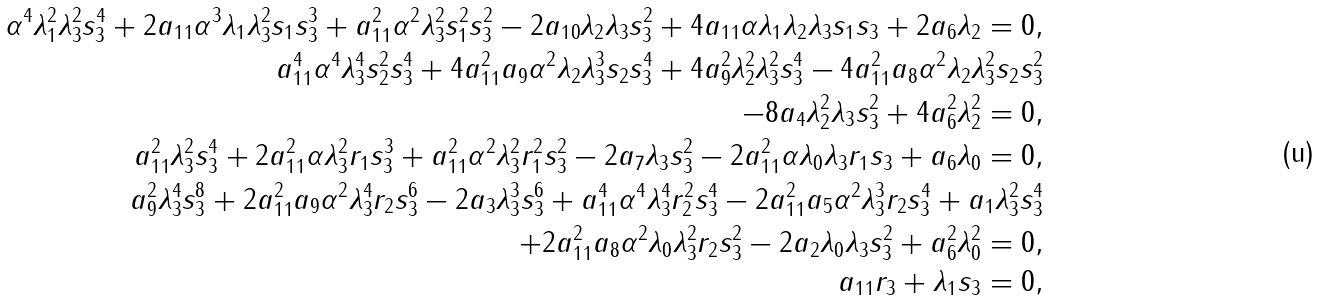<formula> <loc_0><loc_0><loc_500><loc_500>\alpha ^ { 4 } \lambda _ { 1 } ^ { 2 } \lambda _ { 3 } ^ { 2 } s _ { 3 } ^ { 4 } + 2 a _ { 1 1 } \alpha ^ { 3 } \lambda _ { 1 } \lambda _ { 3 } ^ { 2 } s _ { 1 } s _ { 3 } ^ { 3 } + a _ { 1 1 } ^ { 2 } \alpha ^ { 2 } \lambda _ { 3 } ^ { 2 } s _ { 1 } ^ { 2 } s _ { 3 } ^ { 2 } - 2 a _ { 1 0 } \lambda _ { 2 } \lambda _ { 3 } s _ { 3 } ^ { 2 } + 4 a _ { 1 1 } \alpha \lambda _ { 1 } \lambda _ { 2 } \lambda _ { 3 } s _ { 1 } s _ { 3 } + 2 a _ { 6 } \lambda _ { 2 } = 0 , \\ a _ { 1 1 } ^ { 4 } \alpha ^ { 4 } \lambda _ { 3 } ^ { 4 } s _ { 2 } ^ { 2 } s _ { 3 } ^ { 4 } + 4 a _ { 1 1 } ^ { 2 } a _ { 9 } \alpha ^ { 2 } \lambda _ { 2 } \lambda _ { 3 } ^ { 3 } s _ { 2 } s _ { 3 } ^ { 4 } + 4 a _ { 9 } ^ { 2 } \lambda _ { 2 } ^ { 2 } \lambda _ { 3 } ^ { 2 } s _ { 3 } ^ { 4 } - 4 a _ { 1 1 } ^ { 2 } a _ { 8 } \alpha ^ { 2 } \lambda _ { 2 } \lambda _ { 3 } ^ { 2 } s _ { 2 } s _ { 3 } ^ { 2 } \\ - 8 a _ { 4 } \lambda _ { 2 } ^ { 2 } \lambda _ { 3 } s _ { 3 } ^ { 2 } + 4 a _ { 6 } ^ { 2 } \lambda _ { 2 } ^ { 2 } = 0 , \\ a _ { 1 1 } ^ { 2 } \lambda _ { 3 } ^ { 2 } s _ { 3 } ^ { 4 } + 2 a _ { 1 1 } ^ { 2 } \alpha \lambda _ { 3 } ^ { 2 } r _ { 1 } s _ { 3 } ^ { 3 } + a _ { 1 1 } ^ { 2 } \alpha ^ { 2 } \lambda _ { 3 } ^ { 2 } r _ { 1 } ^ { 2 } s _ { 3 } ^ { 2 } - 2 a _ { 7 } \lambda _ { 3 } s _ { 3 } ^ { 2 } - 2 a _ { 1 1 } ^ { 2 } \alpha \lambda _ { 0 } \lambda _ { 3 } r _ { 1 } s _ { 3 } + a _ { 6 } \lambda _ { 0 } = 0 , \\ a _ { 9 } ^ { 2 } \lambda _ { 3 } ^ { 4 } s _ { 3 } ^ { 8 } + 2 a _ { 1 1 } ^ { 2 } a _ { 9 } \alpha ^ { 2 } \lambda _ { 3 } ^ { 4 } r _ { 2 } s _ { 3 } ^ { 6 } - 2 a _ { 3 } \lambda _ { 3 } ^ { 3 } s _ { 3 } ^ { 6 } + a _ { 1 1 } ^ { 4 } \alpha ^ { 4 } \lambda _ { 3 } ^ { 4 } r _ { 2 } ^ { 2 } s _ { 3 } ^ { 4 } - 2 a _ { 1 1 } ^ { 2 } a _ { 5 } \alpha ^ { 2 } \lambda _ { 3 } ^ { 3 } r _ { 2 } s _ { 3 } ^ { 4 } + a _ { 1 } \lambda _ { 3 } ^ { 2 } s _ { 3 } ^ { 4 } \\ + 2 a _ { 1 1 } ^ { 2 } a _ { 8 } \alpha ^ { 2 } \lambda _ { 0 } \lambda _ { 3 } ^ { 2 } r _ { 2 } s _ { 3 } ^ { 2 } - 2 a _ { 2 } \lambda _ { 0 } \lambda _ { 3 } s _ { 3 } ^ { 2 } + a _ { 6 } ^ { 2 } \lambda _ { 0 } ^ { 2 } = 0 , \\ a _ { 1 1 } r _ { 3 } + \lambda _ { 1 } s _ { 3 } = 0 ,</formula> 